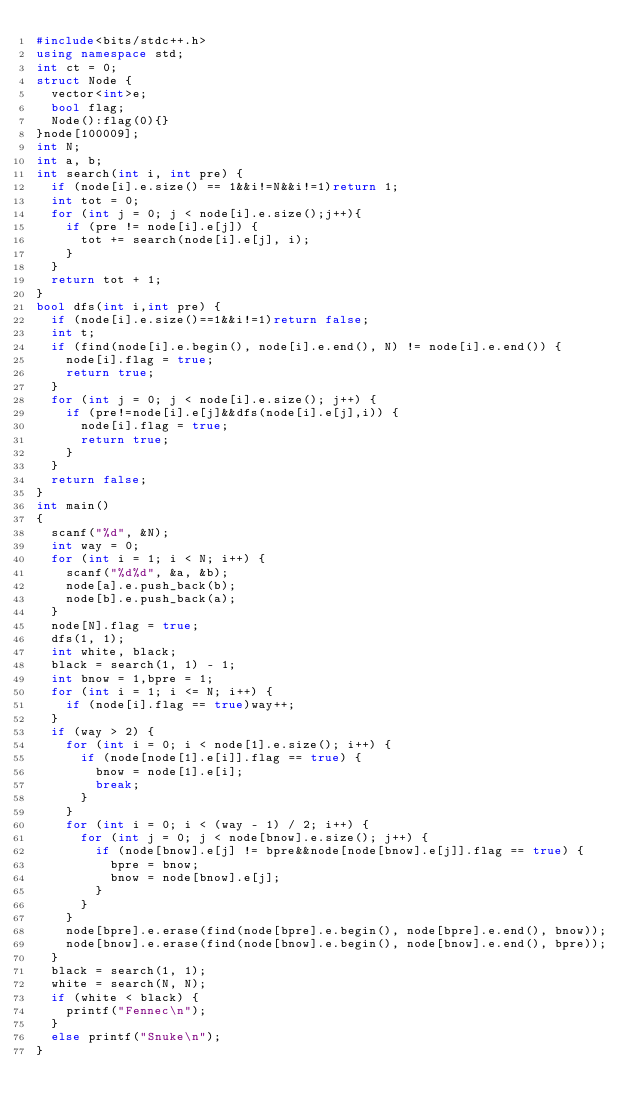Convert code to text. <code><loc_0><loc_0><loc_500><loc_500><_C++_>#include<bits/stdc++.h>
using namespace std;
int ct = 0;
struct Node {
	vector<int>e;
	bool flag;
	Node():flag(0){}
}node[100009];
int N;
int a, b;
int search(int i, int pre) {
	if (node[i].e.size() == 1&&i!=N&&i!=1)return 1;
	int tot = 0;
	for (int j = 0; j < node[i].e.size();j++){
		if (pre != node[i].e[j]) {
			tot += search(node[i].e[j], i);
		}
	}
	return tot + 1;
}
bool dfs(int i,int pre) {
	if (node[i].e.size()==1&&i!=1)return false;
	int t;
	if (find(node[i].e.begin(), node[i].e.end(), N) != node[i].e.end()) {
		node[i].flag = true;
		return true;
	}
	for (int j = 0; j < node[i].e.size(); j++) {
		if (pre!=node[i].e[j]&&dfs(node[i].e[j],i)) {
			node[i].flag = true;
			return true;
		}
	}
	return false;
}
int main()
{
	scanf("%d", &N);
	int way = 0;
	for (int i = 1; i < N; i++) {
		scanf("%d%d", &a, &b);
		node[a].e.push_back(b);
		node[b].e.push_back(a);
	}
	node[N].flag = true;
	dfs(1, 1);
	int white, black;
	black = search(1, 1) - 1;
	int bnow = 1,bpre = 1;
	for (int i = 1; i <= N; i++) {
		if (node[i].flag == true)way++;
	}
	if (way > 2) {
		for (int i = 0; i < node[1].e.size(); i++) {
			if (node[node[1].e[i]].flag == true) {
				bnow = node[1].e[i];
				break;
			}
		}
		for (int i = 0; i < (way - 1) / 2; i++) {
			for (int j = 0; j < node[bnow].e.size(); j++) {
				if (node[bnow].e[j] != bpre&&node[node[bnow].e[j]].flag == true) {
					bpre = bnow;
					bnow = node[bnow].e[j];
				}
			}
		}
		node[bpre].e.erase(find(node[bpre].e.begin(), node[bpre].e.end(), bnow));
		node[bnow].e.erase(find(node[bnow].e.begin(), node[bnow].e.end(), bpre));
	}
	black = search(1, 1);
	white = search(N, N);
	if (white < black) {
		printf("Fennec\n");
	}
	else printf("Snuke\n");
}</code> 